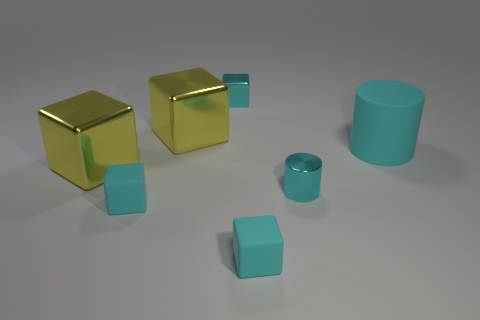There is a large object that is the same color as the tiny metallic block; what material is it?
Give a very brief answer. Rubber. What is the shape of the large cyan rubber object?
Provide a short and direct response. Cylinder. There is a large metallic object that is behind the big rubber thing; what color is it?
Offer a very short reply. Yellow. Do the matte thing on the right side of the cyan metallic cylinder and the small cyan shiny block have the same size?
Make the answer very short. No. There is a cyan metallic thing that is the same shape as the large rubber thing; what size is it?
Give a very brief answer. Small. Are there any other things that have the same size as the cyan rubber cylinder?
Give a very brief answer. Yes. Is the number of large shiny objects that are to the right of the small cyan cylinder less than the number of small cyan blocks on the right side of the big rubber thing?
Ensure brevity in your answer.  No. There is a metallic cylinder; what number of cylinders are behind it?
Offer a terse response. 1. There is a large yellow object that is in front of the big cylinder; is it the same shape as the small cyan metal object that is behind the small cyan cylinder?
Make the answer very short. Yes. How many other objects are there of the same color as the tiny shiny cube?
Offer a terse response. 4. 